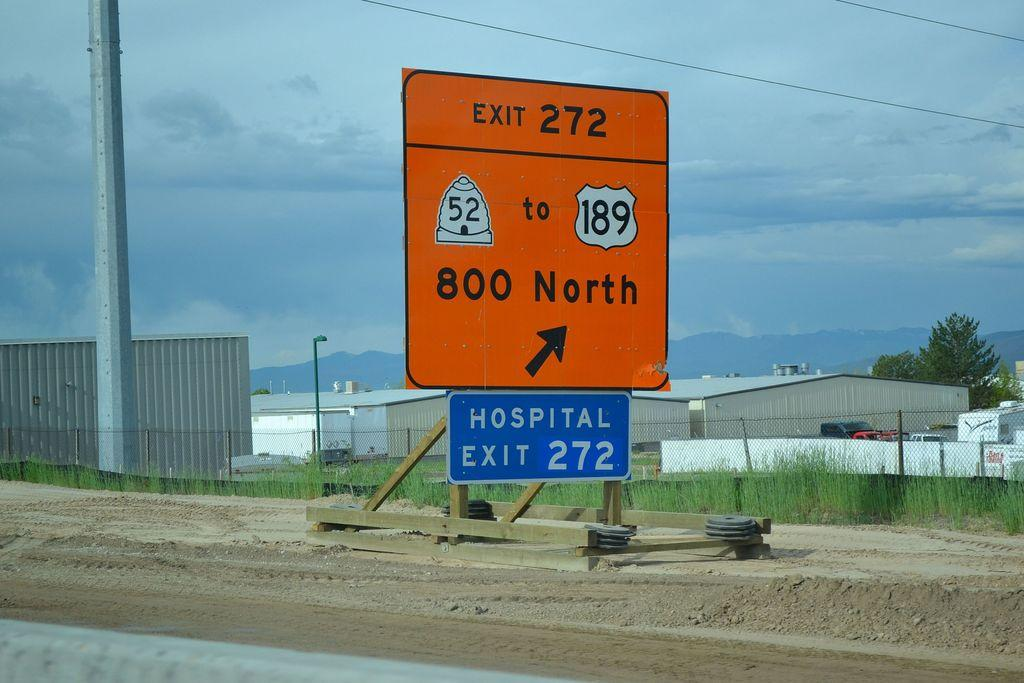<image>
Describe the image concisely. You will find a hospital and 800 North at exit 272. 